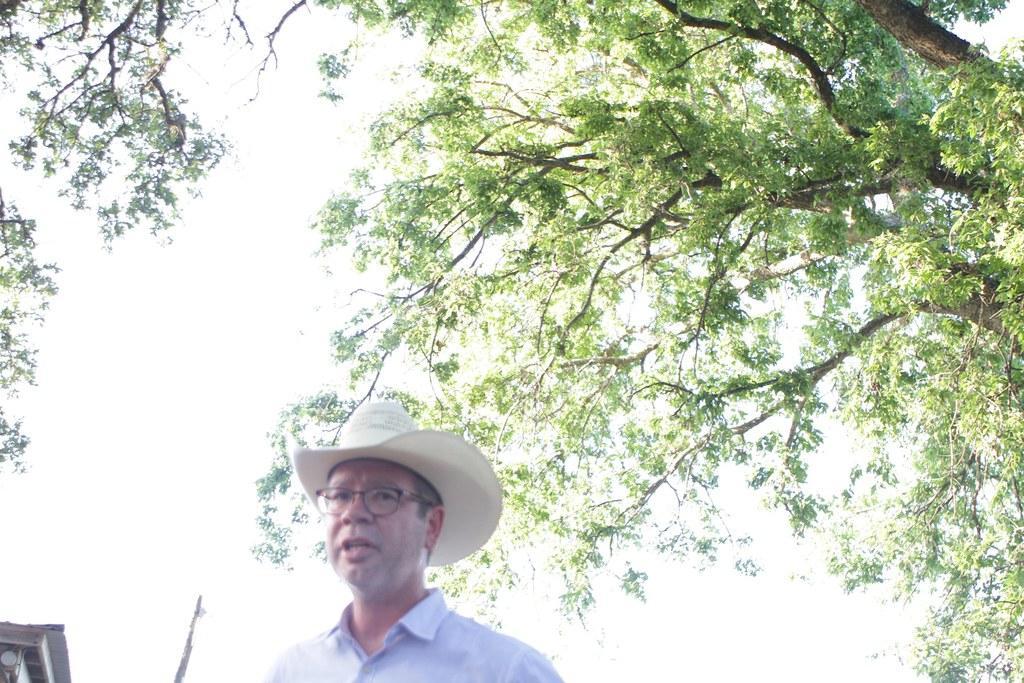Can you describe this image briefly? This picture is clicked outside. In the foreground there is a person wearing blue color shirt at and seems to be talking. In the background there is a sky, tree and a building. 